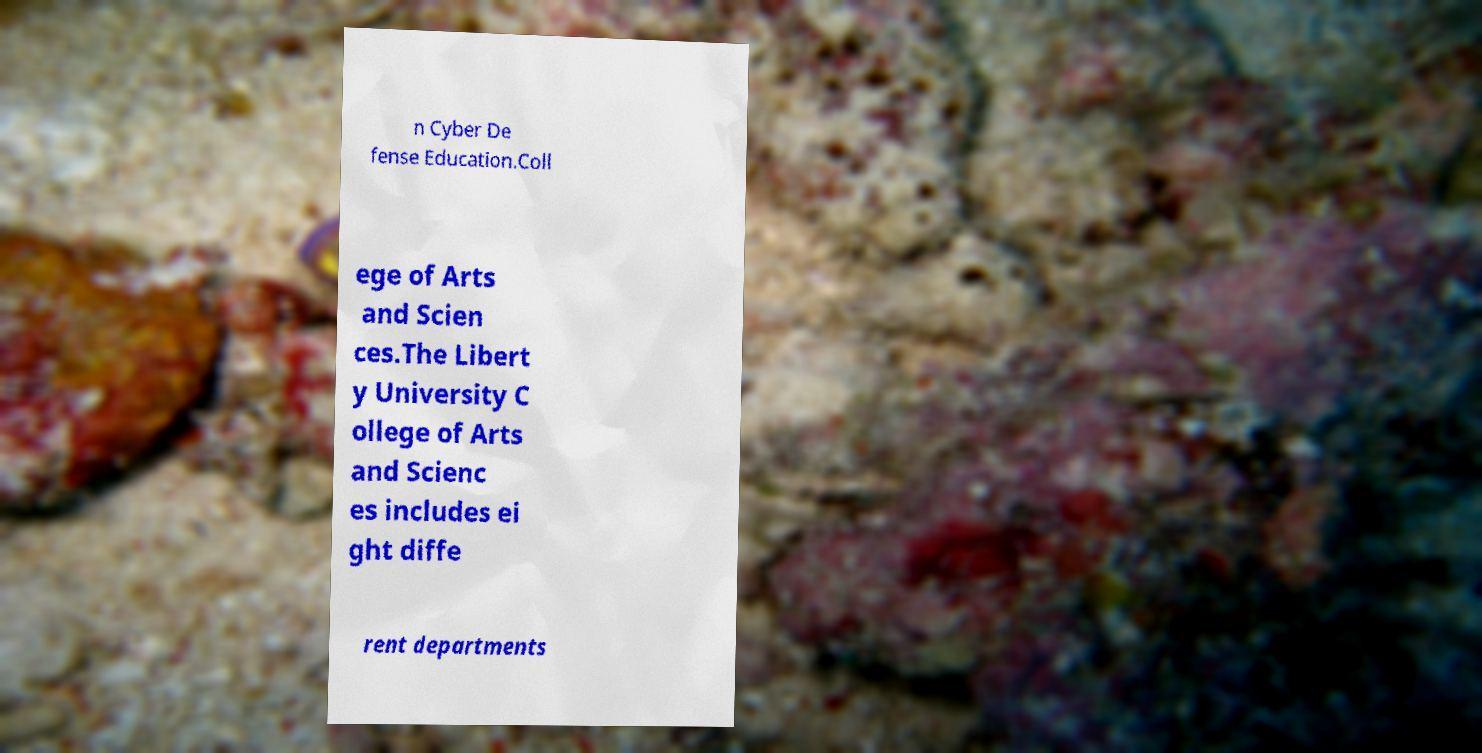Can you read and provide the text displayed in the image?This photo seems to have some interesting text. Can you extract and type it out for me? n Cyber De fense Education.Coll ege of Arts and Scien ces.The Libert y University C ollege of Arts and Scienc es includes ei ght diffe rent departments 